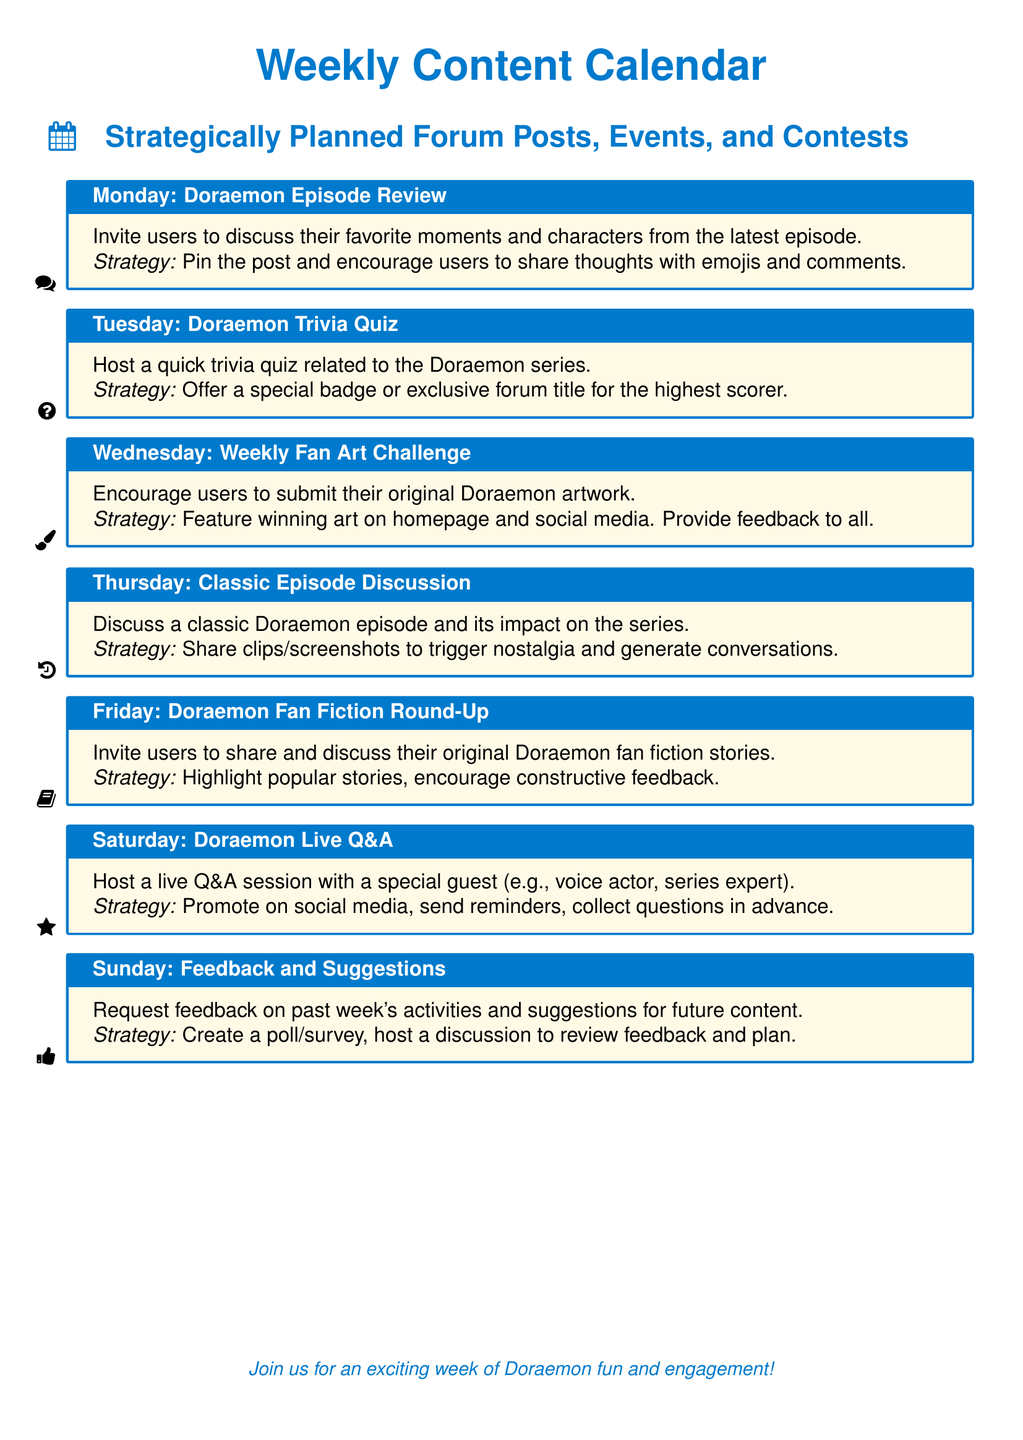What is scheduled for Monday? The document states that there is a Doraemon Episode Review scheduled for Monday.
Answer: Doraemon Episode Review What type of activity is held on Tuesday? The document mentions a Trivia Quiz held on Tuesday related to the Doraemon series.
Answer: Trivia Quiz What incentive is offered for the top scorer in the Tuesday quiz? The document specifies that a special badge or exclusive forum title will be awarded to the highest scorer.
Answer: Special badge or exclusive forum title Which day features a live Q&A session? According to the document, the live Q&A session is scheduled for Saturday with a special guest.
Answer: Saturday What is the strategic focus for the Friday activity? The document describes the strategic focus for Friday's fan fiction round-up as highlighting popular stories and encouraging constructive feedback.
Answer: Highlight popular stories, encourage constructive feedback How is feedback collected on Sunday? The document indicates that feedback on past week's activities is collected through a poll/survey and discussion.
Answer: Poll/survey and discussion What type of content is shared on Wednesday? The document mentions a Weekly Fan Art Challenge, inviting users to submit their original Doraemon artwork.
Answer: Original Doraemon artwork What kind of episodes are discussed on Thursday? The document mentions Classic Episode Discussion taking place on Thursday.
Answer: Classic episodes How are users encouraged to participate in the artwork challenge? The document states that winning art will be featured on the homepage and social media, providing feedback to all.
Answer: Feature winning art, provide feedback 